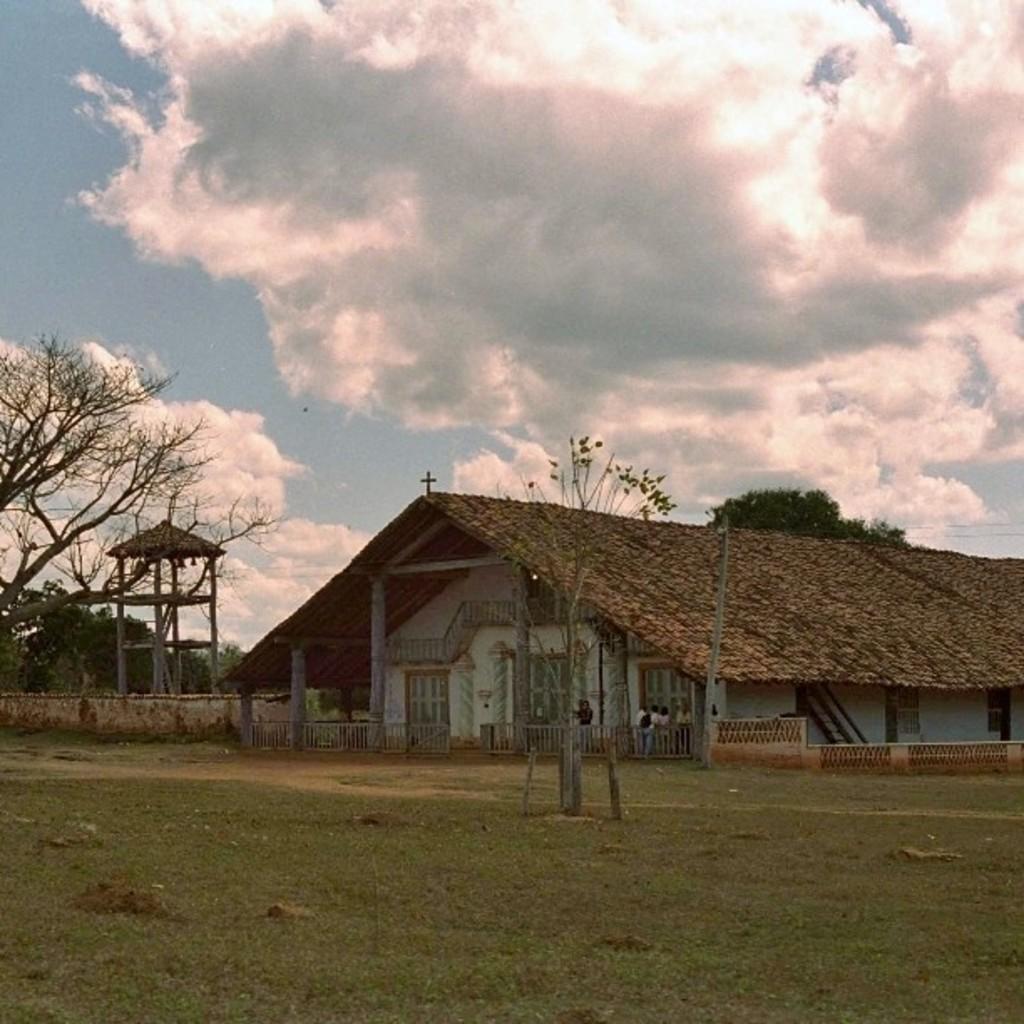Could you give a brief overview of what you see in this image? In this image there is a house, railing and grass. There are trees, people and objects. In the background of the image there is a cloudy sky. 